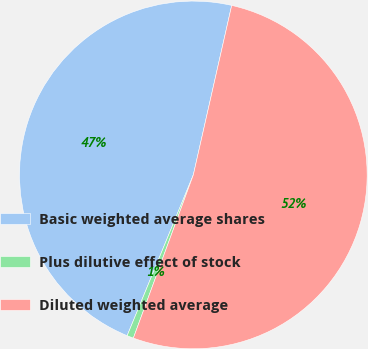Convert chart. <chart><loc_0><loc_0><loc_500><loc_500><pie_chart><fcel>Basic weighted average shares<fcel>Plus dilutive effect of stock<fcel>Diluted weighted average<nl><fcel>47.33%<fcel>0.61%<fcel>52.06%<nl></chart> 